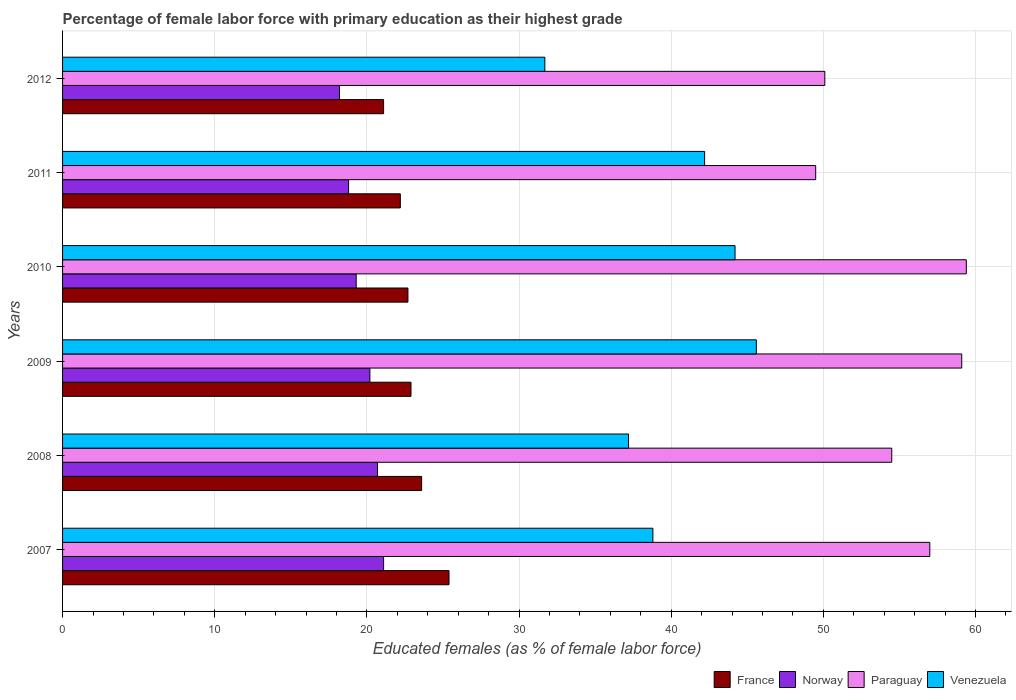How many bars are there on the 4th tick from the top?
Offer a very short reply. 4. How many bars are there on the 2nd tick from the bottom?
Your response must be concise. 4. What is the label of the 5th group of bars from the top?
Your response must be concise. 2008. What is the percentage of female labor force with primary education in Norway in 2012?
Make the answer very short. 18.2. Across all years, what is the maximum percentage of female labor force with primary education in Norway?
Your response must be concise. 21.1. Across all years, what is the minimum percentage of female labor force with primary education in Venezuela?
Give a very brief answer. 31.7. What is the total percentage of female labor force with primary education in Paraguay in the graph?
Offer a very short reply. 329.6. What is the difference between the percentage of female labor force with primary education in Venezuela in 2011 and that in 2012?
Ensure brevity in your answer.  10.5. What is the difference between the percentage of female labor force with primary education in Norway in 2008 and the percentage of female labor force with primary education in France in 2012?
Give a very brief answer. -0.4. What is the average percentage of female labor force with primary education in Venezuela per year?
Your response must be concise. 39.95. In the year 2011, what is the difference between the percentage of female labor force with primary education in Norway and percentage of female labor force with primary education in Paraguay?
Your response must be concise. -30.7. What is the ratio of the percentage of female labor force with primary education in France in 2009 to that in 2010?
Offer a very short reply. 1.01. What is the difference between the highest and the second highest percentage of female labor force with primary education in France?
Give a very brief answer. 1.8. What is the difference between the highest and the lowest percentage of female labor force with primary education in Venezuela?
Your answer should be compact. 13.9. Is the sum of the percentage of female labor force with primary education in France in 2009 and 2010 greater than the maximum percentage of female labor force with primary education in Venezuela across all years?
Keep it short and to the point. Yes. Is it the case that in every year, the sum of the percentage of female labor force with primary education in Paraguay and percentage of female labor force with primary education in France is greater than the sum of percentage of female labor force with primary education in Venezuela and percentage of female labor force with primary education in Norway?
Provide a succinct answer. No. What does the 2nd bar from the top in 2009 represents?
Offer a very short reply. Paraguay. Is it the case that in every year, the sum of the percentage of female labor force with primary education in Norway and percentage of female labor force with primary education in France is greater than the percentage of female labor force with primary education in Paraguay?
Make the answer very short. No. How many bars are there?
Provide a succinct answer. 24. What is the difference between two consecutive major ticks on the X-axis?
Offer a very short reply. 10. Does the graph contain any zero values?
Provide a succinct answer. No. Does the graph contain grids?
Provide a succinct answer. Yes. Where does the legend appear in the graph?
Your answer should be compact. Bottom right. How are the legend labels stacked?
Offer a very short reply. Horizontal. What is the title of the graph?
Offer a very short reply. Percentage of female labor force with primary education as their highest grade. Does "Jordan" appear as one of the legend labels in the graph?
Your response must be concise. No. What is the label or title of the X-axis?
Give a very brief answer. Educated females (as % of female labor force). What is the Educated females (as % of female labor force) in France in 2007?
Give a very brief answer. 25.4. What is the Educated females (as % of female labor force) in Norway in 2007?
Ensure brevity in your answer.  21.1. What is the Educated females (as % of female labor force) of Paraguay in 2007?
Your response must be concise. 57. What is the Educated females (as % of female labor force) in Venezuela in 2007?
Your answer should be very brief. 38.8. What is the Educated females (as % of female labor force) in France in 2008?
Offer a very short reply. 23.6. What is the Educated females (as % of female labor force) of Norway in 2008?
Ensure brevity in your answer.  20.7. What is the Educated females (as % of female labor force) of Paraguay in 2008?
Provide a succinct answer. 54.5. What is the Educated females (as % of female labor force) in Venezuela in 2008?
Provide a succinct answer. 37.2. What is the Educated females (as % of female labor force) of France in 2009?
Provide a succinct answer. 22.9. What is the Educated females (as % of female labor force) of Norway in 2009?
Offer a very short reply. 20.2. What is the Educated females (as % of female labor force) in Paraguay in 2009?
Your answer should be very brief. 59.1. What is the Educated females (as % of female labor force) in Venezuela in 2009?
Your response must be concise. 45.6. What is the Educated females (as % of female labor force) of France in 2010?
Ensure brevity in your answer.  22.7. What is the Educated females (as % of female labor force) of Norway in 2010?
Offer a very short reply. 19.3. What is the Educated females (as % of female labor force) in Paraguay in 2010?
Give a very brief answer. 59.4. What is the Educated females (as % of female labor force) of Venezuela in 2010?
Your answer should be very brief. 44.2. What is the Educated females (as % of female labor force) in France in 2011?
Provide a short and direct response. 22.2. What is the Educated females (as % of female labor force) in Norway in 2011?
Give a very brief answer. 18.8. What is the Educated females (as % of female labor force) in Paraguay in 2011?
Provide a short and direct response. 49.5. What is the Educated females (as % of female labor force) in Venezuela in 2011?
Ensure brevity in your answer.  42.2. What is the Educated females (as % of female labor force) in France in 2012?
Keep it short and to the point. 21.1. What is the Educated females (as % of female labor force) in Norway in 2012?
Make the answer very short. 18.2. What is the Educated females (as % of female labor force) of Paraguay in 2012?
Offer a very short reply. 50.1. What is the Educated females (as % of female labor force) in Venezuela in 2012?
Your answer should be compact. 31.7. Across all years, what is the maximum Educated females (as % of female labor force) in France?
Offer a very short reply. 25.4. Across all years, what is the maximum Educated females (as % of female labor force) of Norway?
Offer a terse response. 21.1. Across all years, what is the maximum Educated females (as % of female labor force) in Paraguay?
Offer a very short reply. 59.4. Across all years, what is the maximum Educated females (as % of female labor force) in Venezuela?
Make the answer very short. 45.6. Across all years, what is the minimum Educated females (as % of female labor force) of France?
Your answer should be very brief. 21.1. Across all years, what is the minimum Educated females (as % of female labor force) in Norway?
Ensure brevity in your answer.  18.2. Across all years, what is the minimum Educated females (as % of female labor force) of Paraguay?
Offer a terse response. 49.5. Across all years, what is the minimum Educated females (as % of female labor force) of Venezuela?
Give a very brief answer. 31.7. What is the total Educated females (as % of female labor force) in France in the graph?
Provide a short and direct response. 137.9. What is the total Educated females (as % of female labor force) of Norway in the graph?
Ensure brevity in your answer.  118.3. What is the total Educated females (as % of female labor force) of Paraguay in the graph?
Make the answer very short. 329.6. What is the total Educated females (as % of female labor force) in Venezuela in the graph?
Offer a very short reply. 239.7. What is the difference between the Educated females (as % of female labor force) in France in 2007 and that in 2008?
Make the answer very short. 1.8. What is the difference between the Educated females (as % of female labor force) in Paraguay in 2007 and that in 2008?
Provide a short and direct response. 2.5. What is the difference between the Educated females (as % of female labor force) in Venezuela in 2007 and that in 2008?
Provide a succinct answer. 1.6. What is the difference between the Educated females (as % of female labor force) in Norway in 2007 and that in 2009?
Give a very brief answer. 0.9. What is the difference between the Educated females (as % of female labor force) in Venezuela in 2007 and that in 2009?
Your answer should be very brief. -6.8. What is the difference between the Educated females (as % of female labor force) in France in 2007 and that in 2010?
Give a very brief answer. 2.7. What is the difference between the Educated females (as % of female labor force) of France in 2007 and that in 2011?
Offer a terse response. 3.2. What is the difference between the Educated females (as % of female labor force) in Norway in 2007 and that in 2011?
Your answer should be compact. 2.3. What is the difference between the Educated females (as % of female labor force) of Paraguay in 2007 and that in 2011?
Provide a short and direct response. 7.5. What is the difference between the Educated females (as % of female labor force) in Norway in 2007 and that in 2012?
Give a very brief answer. 2.9. What is the difference between the Educated females (as % of female labor force) of Paraguay in 2007 and that in 2012?
Provide a short and direct response. 6.9. What is the difference between the Educated females (as % of female labor force) of Norway in 2008 and that in 2009?
Your answer should be compact. 0.5. What is the difference between the Educated females (as % of female labor force) of Venezuela in 2008 and that in 2009?
Your response must be concise. -8.4. What is the difference between the Educated females (as % of female labor force) of France in 2008 and that in 2010?
Your answer should be very brief. 0.9. What is the difference between the Educated females (as % of female labor force) in Paraguay in 2008 and that in 2010?
Keep it short and to the point. -4.9. What is the difference between the Educated females (as % of female labor force) of Norway in 2008 and that in 2011?
Ensure brevity in your answer.  1.9. What is the difference between the Educated females (as % of female labor force) in Paraguay in 2008 and that in 2011?
Offer a terse response. 5. What is the difference between the Educated females (as % of female labor force) in Venezuela in 2008 and that in 2011?
Your answer should be very brief. -5. What is the difference between the Educated females (as % of female labor force) of Paraguay in 2008 and that in 2012?
Your response must be concise. 4.4. What is the difference between the Educated females (as % of female labor force) in Venezuela in 2008 and that in 2012?
Your answer should be very brief. 5.5. What is the difference between the Educated females (as % of female labor force) of France in 2009 and that in 2010?
Keep it short and to the point. 0.2. What is the difference between the Educated females (as % of female labor force) of Norway in 2009 and that in 2010?
Your answer should be very brief. 0.9. What is the difference between the Educated females (as % of female labor force) in Norway in 2009 and that in 2011?
Your answer should be very brief. 1.4. What is the difference between the Educated females (as % of female labor force) in Paraguay in 2009 and that in 2011?
Your answer should be very brief. 9.6. What is the difference between the Educated females (as % of female labor force) of Venezuela in 2009 and that in 2011?
Your response must be concise. 3.4. What is the difference between the Educated females (as % of female labor force) of France in 2010 and that in 2011?
Offer a very short reply. 0.5. What is the difference between the Educated females (as % of female labor force) in Paraguay in 2010 and that in 2011?
Provide a succinct answer. 9.9. What is the difference between the Educated females (as % of female labor force) in France in 2010 and that in 2012?
Give a very brief answer. 1.6. What is the difference between the Educated females (as % of female labor force) of Paraguay in 2010 and that in 2012?
Keep it short and to the point. 9.3. What is the difference between the Educated females (as % of female labor force) in Venezuela in 2010 and that in 2012?
Your answer should be compact. 12.5. What is the difference between the Educated females (as % of female labor force) of Paraguay in 2011 and that in 2012?
Your answer should be compact. -0.6. What is the difference between the Educated females (as % of female labor force) of France in 2007 and the Educated females (as % of female labor force) of Norway in 2008?
Your answer should be very brief. 4.7. What is the difference between the Educated females (as % of female labor force) of France in 2007 and the Educated females (as % of female labor force) of Paraguay in 2008?
Give a very brief answer. -29.1. What is the difference between the Educated females (as % of female labor force) of Norway in 2007 and the Educated females (as % of female labor force) of Paraguay in 2008?
Your answer should be compact. -33.4. What is the difference between the Educated females (as % of female labor force) of Norway in 2007 and the Educated females (as % of female labor force) of Venezuela in 2008?
Give a very brief answer. -16.1. What is the difference between the Educated females (as % of female labor force) in Paraguay in 2007 and the Educated females (as % of female labor force) in Venezuela in 2008?
Your answer should be compact. 19.8. What is the difference between the Educated females (as % of female labor force) in France in 2007 and the Educated females (as % of female labor force) in Norway in 2009?
Your answer should be compact. 5.2. What is the difference between the Educated females (as % of female labor force) in France in 2007 and the Educated females (as % of female labor force) in Paraguay in 2009?
Your answer should be compact. -33.7. What is the difference between the Educated females (as % of female labor force) of France in 2007 and the Educated females (as % of female labor force) of Venezuela in 2009?
Offer a very short reply. -20.2. What is the difference between the Educated females (as % of female labor force) in Norway in 2007 and the Educated females (as % of female labor force) in Paraguay in 2009?
Make the answer very short. -38. What is the difference between the Educated females (as % of female labor force) in Norway in 2007 and the Educated females (as % of female labor force) in Venezuela in 2009?
Your response must be concise. -24.5. What is the difference between the Educated females (as % of female labor force) in France in 2007 and the Educated females (as % of female labor force) in Paraguay in 2010?
Offer a terse response. -34. What is the difference between the Educated females (as % of female labor force) in France in 2007 and the Educated females (as % of female labor force) in Venezuela in 2010?
Your answer should be very brief. -18.8. What is the difference between the Educated females (as % of female labor force) of Norway in 2007 and the Educated females (as % of female labor force) of Paraguay in 2010?
Offer a terse response. -38.3. What is the difference between the Educated females (as % of female labor force) in Norway in 2007 and the Educated females (as % of female labor force) in Venezuela in 2010?
Provide a succinct answer. -23.1. What is the difference between the Educated females (as % of female labor force) of France in 2007 and the Educated females (as % of female labor force) of Paraguay in 2011?
Keep it short and to the point. -24.1. What is the difference between the Educated females (as % of female labor force) of France in 2007 and the Educated females (as % of female labor force) of Venezuela in 2011?
Your answer should be very brief. -16.8. What is the difference between the Educated females (as % of female labor force) in Norway in 2007 and the Educated females (as % of female labor force) in Paraguay in 2011?
Ensure brevity in your answer.  -28.4. What is the difference between the Educated females (as % of female labor force) in Norway in 2007 and the Educated females (as % of female labor force) in Venezuela in 2011?
Ensure brevity in your answer.  -21.1. What is the difference between the Educated females (as % of female labor force) of Paraguay in 2007 and the Educated females (as % of female labor force) of Venezuela in 2011?
Give a very brief answer. 14.8. What is the difference between the Educated females (as % of female labor force) in France in 2007 and the Educated females (as % of female labor force) in Norway in 2012?
Your answer should be very brief. 7.2. What is the difference between the Educated females (as % of female labor force) of France in 2007 and the Educated females (as % of female labor force) of Paraguay in 2012?
Provide a succinct answer. -24.7. What is the difference between the Educated females (as % of female labor force) in France in 2007 and the Educated females (as % of female labor force) in Venezuela in 2012?
Make the answer very short. -6.3. What is the difference between the Educated females (as % of female labor force) of Norway in 2007 and the Educated females (as % of female labor force) of Paraguay in 2012?
Provide a short and direct response. -29. What is the difference between the Educated females (as % of female labor force) in Norway in 2007 and the Educated females (as % of female labor force) in Venezuela in 2012?
Offer a terse response. -10.6. What is the difference between the Educated females (as % of female labor force) in Paraguay in 2007 and the Educated females (as % of female labor force) in Venezuela in 2012?
Give a very brief answer. 25.3. What is the difference between the Educated females (as % of female labor force) in France in 2008 and the Educated females (as % of female labor force) in Norway in 2009?
Your answer should be compact. 3.4. What is the difference between the Educated females (as % of female labor force) in France in 2008 and the Educated females (as % of female labor force) in Paraguay in 2009?
Your answer should be compact. -35.5. What is the difference between the Educated females (as % of female labor force) of France in 2008 and the Educated females (as % of female labor force) of Venezuela in 2009?
Keep it short and to the point. -22. What is the difference between the Educated females (as % of female labor force) of Norway in 2008 and the Educated females (as % of female labor force) of Paraguay in 2009?
Make the answer very short. -38.4. What is the difference between the Educated females (as % of female labor force) in Norway in 2008 and the Educated females (as % of female labor force) in Venezuela in 2009?
Your answer should be compact. -24.9. What is the difference between the Educated females (as % of female labor force) of France in 2008 and the Educated females (as % of female labor force) of Paraguay in 2010?
Give a very brief answer. -35.8. What is the difference between the Educated females (as % of female labor force) in France in 2008 and the Educated females (as % of female labor force) in Venezuela in 2010?
Give a very brief answer. -20.6. What is the difference between the Educated females (as % of female labor force) in Norway in 2008 and the Educated females (as % of female labor force) in Paraguay in 2010?
Make the answer very short. -38.7. What is the difference between the Educated females (as % of female labor force) of Norway in 2008 and the Educated females (as % of female labor force) of Venezuela in 2010?
Give a very brief answer. -23.5. What is the difference between the Educated females (as % of female labor force) of France in 2008 and the Educated females (as % of female labor force) of Norway in 2011?
Offer a terse response. 4.8. What is the difference between the Educated females (as % of female labor force) in France in 2008 and the Educated females (as % of female labor force) in Paraguay in 2011?
Ensure brevity in your answer.  -25.9. What is the difference between the Educated females (as % of female labor force) in France in 2008 and the Educated females (as % of female labor force) in Venezuela in 2011?
Keep it short and to the point. -18.6. What is the difference between the Educated females (as % of female labor force) of Norway in 2008 and the Educated females (as % of female labor force) of Paraguay in 2011?
Make the answer very short. -28.8. What is the difference between the Educated females (as % of female labor force) of Norway in 2008 and the Educated females (as % of female labor force) of Venezuela in 2011?
Make the answer very short. -21.5. What is the difference between the Educated females (as % of female labor force) in France in 2008 and the Educated females (as % of female labor force) in Norway in 2012?
Your answer should be very brief. 5.4. What is the difference between the Educated females (as % of female labor force) in France in 2008 and the Educated females (as % of female labor force) in Paraguay in 2012?
Make the answer very short. -26.5. What is the difference between the Educated females (as % of female labor force) of Norway in 2008 and the Educated females (as % of female labor force) of Paraguay in 2012?
Provide a short and direct response. -29.4. What is the difference between the Educated females (as % of female labor force) of Paraguay in 2008 and the Educated females (as % of female labor force) of Venezuela in 2012?
Give a very brief answer. 22.8. What is the difference between the Educated females (as % of female labor force) of France in 2009 and the Educated females (as % of female labor force) of Norway in 2010?
Your response must be concise. 3.6. What is the difference between the Educated females (as % of female labor force) in France in 2009 and the Educated females (as % of female labor force) in Paraguay in 2010?
Your response must be concise. -36.5. What is the difference between the Educated females (as % of female labor force) in France in 2009 and the Educated females (as % of female labor force) in Venezuela in 2010?
Provide a short and direct response. -21.3. What is the difference between the Educated females (as % of female labor force) in Norway in 2009 and the Educated females (as % of female labor force) in Paraguay in 2010?
Provide a succinct answer. -39.2. What is the difference between the Educated females (as % of female labor force) in Norway in 2009 and the Educated females (as % of female labor force) in Venezuela in 2010?
Provide a short and direct response. -24. What is the difference between the Educated females (as % of female labor force) of Paraguay in 2009 and the Educated females (as % of female labor force) of Venezuela in 2010?
Your response must be concise. 14.9. What is the difference between the Educated females (as % of female labor force) in France in 2009 and the Educated females (as % of female labor force) in Norway in 2011?
Keep it short and to the point. 4.1. What is the difference between the Educated females (as % of female labor force) in France in 2009 and the Educated females (as % of female labor force) in Paraguay in 2011?
Offer a very short reply. -26.6. What is the difference between the Educated females (as % of female labor force) in France in 2009 and the Educated females (as % of female labor force) in Venezuela in 2011?
Your answer should be very brief. -19.3. What is the difference between the Educated females (as % of female labor force) in Norway in 2009 and the Educated females (as % of female labor force) in Paraguay in 2011?
Give a very brief answer. -29.3. What is the difference between the Educated females (as % of female labor force) in Norway in 2009 and the Educated females (as % of female labor force) in Venezuela in 2011?
Keep it short and to the point. -22. What is the difference between the Educated females (as % of female labor force) of France in 2009 and the Educated females (as % of female labor force) of Paraguay in 2012?
Offer a terse response. -27.2. What is the difference between the Educated females (as % of female labor force) in France in 2009 and the Educated females (as % of female labor force) in Venezuela in 2012?
Offer a terse response. -8.8. What is the difference between the Educated females (as % of female labor force) of Norway in 2009 and the Educated females (as % of female labor force) of Paraguay in 2012?
Offer a very short reply. -29.9. What is the difference between the Educated females (as % of female labor force) of Paraguay in 2009 and the Educated females (as % of female labor force) of Venezuela in 2012?
Offer a terse response. 27.4. What is the difference between the Educated females (as % of female labor force) of France in 2010 and the Educated females (as % of female labor force) of Paraguay in 2011?
Give a very brief answer. -26.8. What is the difference between the Educated females (as % of female labor force) in France in 2010 and the Educated females (as % of female labor force) in Venezuela in 2011?
Offer a terse response. -19.5. What is the difference between the Educated females (as % of female labor force) in Norway in 2010 and the Educated females (as % of female labor force) in Paraguay in 2011?
Your answer should be compact. -30.2. What is the difference between the Educated females (as % of female labor force) of Norway in 2010 and the Educated females (as % of female labor force) of Venezuela in 2011?
Make the answer very short. -22.9. What is the difference between the Educated females (as % of female labor force) of France in 2010 and the Educated females (as % of female labor force) of Paraguay in 2012?
Keep it short and to the point. -27.4. What is the difference between the Educated females (as % of female labor force) in Norway in 2010 and the Educated females (as % of female labor force) in Paraguay in 2012?
Your response must be concise. -30.8. What is the difference between the Educated females (as % of female labor force) of Norway in 2010 and the Educated females (as % of female labor force) of Venezuela in 2012?
Your answer should be very brief. -12.4. What is the difference between the Educated females (as % of female labor force) in Paraguay in 2010 and the Educated females (as % of female labor force) in Venezuela in 2012?
Your response must be concise. 27.7. What is the difference between the Educated females (as % of female labor force) of France in 2011 and the Educated females (as % of female labor force) of Norway in 2012?
Offer a terse response. 4. What is the difference between the Educated females (as % of female labor force) in France in 2011 and the Educated females (as % of female labor force) in Paraguay in 2012?
Your answer should be compact. -27.9. What is the difference between the Educated females (as % of female labor force) of Norway in 2011 and the Educated females (as % of female labor force) of Paraguay in 2012?
Keep it short and to the point. -31.3. What is the average Educated females (as % of female labor force) of France per year?
Provide a short and direct response. 22.98. What is the average Educated females (as % of female labor force) in Norway per year?
Keep it short and to the point. 19.72. What is the average Educated females (as % of female labor force) in Paraguay per year?
Provide a short and direct response. 54.93. What is the average Educated females (as % of female labor force) of Venezuela per year?
Provide a short and direct response. 39.95. In the year 2007, what is the difference between the Educated females (as % of female labor force) of France and Educated females (as % of female labor force) of Norway?
Make the answer very short. 4.3. In the year 2007, what is the difference between the Educated females (as % of female labor force) in France and Educated females (as % of female labor force) in Paraguay?
Your response must be concise. -31.6. In the year 2007, what is the difference between the Educated females (as % of female labor force) of Norway and Educated females (as % of female labor force) of Paraguay?
Give a very brief answer. -35.9. In the year 2007, what is the difference between the Educated females (as % of female labor force) in Norway and Educated females (as % of female labor force) in Venezuela?
Offer a very short reply. -17.7. In the year 2007, what is the difference between the Educated females (as % of female labor force) of Paraguay and Educated females (as % of female labor force) of Venezuela?
Offer a very short reply. 18.2. In the year 2008, what is the difference between the Educated females (as % of female labor force) in France and Educated females (as % of female labor force) in Norway?
Provide a short and direct response. 2.9. In the year 2008, what is the difference between the Educated females (as % of female labor force) in France and Educated females (as % of female labor force) in Paraguay?
Your answer should be very brief. -30.9. In the year 2008, what is the difference between the Educated females (as % of female labor force) of Norway and Educated females (as % of female labor force) of Paraguay?
Provide a short and direct response. -33.8. In the year 2008, what is the difference between the Educated females (as % of female labor force) of Norway and Educated females (as % of female labor force) of Venezuela?
Provide a short and direct response. -16.5. In the year 2009, what is the difference between the Educated females (as % of female labor force) of France and Educated females (as % of female labor force) of Paraguay?
Ensure brevity in your answer.  -36.2. In the year 2009, what is the difference between the Educated females (as % of female labor force) in France and Educated females (as % of female labor force) in Venezuela?
Your response must be concise. -22.7. In the year 2009, what is the difference between the Educated females (as % of female labor force) of Norway and Educated females (as % of female labor force) of Paraguay?
Provide a short and direct response. -38.9. In the year 2009, what is the difference between the Educated females (as % of female labor force) in Norway and Educated females (as % of female labor force) in Venezuela?
Make the answer very short. -25.4. In the year 2009, what is the difference between the Educated females (as % of female labor force) of Paraguay and Educated females (as % of female labor force) of Venezuela?
Provide a succinct answer. 13.5. In the year 2010, what is the difference between the Educated females (as % of female labor force) of France and Educated females (as % of female labor force) of Norway?
Make the answer very short. 3.4. In the year 2010, what is the difference between the Educated females (as % of female labor force) of France and Educated females (as % of female labor force) of Paraguay?
Offer a terse response. -36.7. In the year 2010, what is the difference between the Educated females (as % of female labor force) in France and Educated females (as % of female labor force) in Venezuela?
Your answer should be compact. -21.5. In the year 2010, what is the difference between the Educated females (as % of female labor force) in Norway and Educated females (as % of female labor force) in Paraguay?
Ensure brevity in your answer.  -40.1. In the year 2010, what is the difference between the Educated females (as % of female labor force) of Norway and Educated females (as % of female labor force) of Venezuela?
Offer a very short reply. -24.9. In the year 2011, what is the difference between the Educated females (as % of female labor force) of France and Educated females (as % of female labor force) of Paraguay?
Make the answer very short. -27.3. In the year 2011, what is the difference between the Educated females (as % of female labor force) in France and Educated females (as % of female labor force) in Venezuela?
Your answer should be compact. -20. In the year 2011, what is the difference between the Educated females (as % of female labor force) of Norway and Educated females (as % of female labor force) of Paraguay?
Give a very brief answer. -30.7. In the year 2011, what is the difference between the Educated females (as % of female labor force) in Norway and Educated females (as % of female labor force) in Venezuela?
Keep it short and to the point. -23.4. In the year 2012, what is the difference between the Educated females (as % of female labor force) in France and Educated females (as % of female labor force) in Norway?
Make the answer very short. 2.9. In the year 2012, what is the difference between the Educated females (as % of female labor force) in Norway and Educated females (as % of female labor force) in Paraguay?
Your response must be concise. -31.9. In the year 2012, what is the difference between the Educated females (as % of female labor force) in Norway and Educated females (as % of female labor force) in Venezuela?
Ensure brevity in your answer.  -13.5. In the year 2012, what is the difference between the Educated females (as % of female labor force) in Paraguay and Educated females (as % of female labor force) in Venezuela?
Your response must be concise. 18.4. What is the ratio of the Educated females (as % of female labor force) of France in 2007 to that in 2008?
Your answer should be very brief. 1.08. What is the ratio of the Educated females (as % of female labor force) in Norway in 2007 to that in 2008?
Offer a very short reply. 1.02. What is the ratio of the Educated females (as % of female labor force) of Paraguay in 2007 to that in 2008?
Provide a succinct answer. 1.05. What is the ratio of the Educated females (as % of female labor force) in Venezuela in 2007 to that in 2008?
Your answer should be very brief. 1.04. What is the ratio of the Educated females (as % of female labor force) in France in 2007 to that in 2009?
Your answer should be very brief. 1.11. What is the ratio of the Educated females (as % of female labor force) of Norway in 2007 to that in 2009?
Keep it short and to the point. 1.04. What is the ratio of the Educated females (as % of female labor force) of Paraguay in 2007 to that in 2009?
Your answer should be compact. 0.96. What is the ratio of the Educated females (as % of female labor force) of Venezuela in 2007 to that in 2009?
Your answer should be compact. 0.85. What is the ratio of the Educated females (as % of female labor force) of France in 2007 to that in 2010?
Your answer should be very brief. 1.12. What is the ratio of the Educated females (as % of female labor force) of Norway in 2007 to that in 2010?
Offer a very short reply. 1.09. What is the ratio of the Educated females (as % of female labor force) of Paraguay in 2007 to that in 2010?
Provide a short and direct response. 0.96. What is the ratio of the Educated females (as % of female labor force) in Venezuela in 2007 to that in 2010?
Your response must be concise. 0.88. What is the ratio of the Educated females (as % of female labor force) of France in 2007 to that in 2011?
Give a very brief answer. 1.14. What is the ratio of the Educated females (as % of female labor force) in Norway in 2007 to that in 2011?
Provide a succinct answer. 1.12. What is the ratio of the Educated females (as % of female labor force) of Paraguay in 2007 to that in 2011?
Offer a terse response. 1.15. What is the ratio of the Educated females (as % of female labor force) in Venezuela in 2007 to that in 2011?
Your response must be concise. 0.92. What is the ratio of the Educated females (as % of female labor force) in France in 2007 to that in 2012?
Give a very brief answer. 1.2. What is the ratio of the Educated females (as % of female labor force) of Norway in 2007 to that in 2012?
Offer a terse response. 1.16. What is the ratio of the Educated females (as % of female labor force) in Paraguay in 2007 to that in 2012?
Offer a terse response. 1.14. What is the ratio of the Educated females (as % of female labor force) of Venezuela in 2007 to that in 2012?
Your answer should be compact. 1.22. What is the ratio of the Educated females (as % of female labor force) in France in 2008 to that in 2009?
Offer a very short reply. 1.03. What is the ratio of the Educated females (as % of female labor force) in Norway in 2008 to that in 2009?
Ensure brevity in your answer.  1.02. What is the ratio of the Educated females (as % of female labor force) in Paraguay in 2008 to that in 2009?
Provide a succinct answer. 0.92. What is the ratio of the Educated females (as % of female labor force) in Venezuela in 2008 to that in 2009?
Provide a short and direct response. 0.82. What is the ratio of the Educated females (as % of female labor force) in France in 2008 to that in 2010?
Make the answer very short. 1.04. What is the ratio of the Educated females (as % of female labor force) of Norway in 2008 to that in 2010?
Your answer should be compact. 1.07. What is the ratio of the Educated females (as % of female labor force) in Paraguay in 2008 to that in 2010?
Offer a terse response. 0.92. What is the ratio of the Educated females (as % of female labor force) in Venezuela in 2008 to that in 2010?
Offer a very short reply. 0.84. What is the ratio of the Educated females (as % of female labor force) of France in 2008 to that in 2011?
Provide a succinct answer. 1.06. What is the ratio of the Educated females (as % of female labor force) in Norway in 2008 to that in 2011?
Make the answer very short. 1.1. What is the ratio of the Educated females (as % of female labor force) of Paraguay in 2008 to that in 2011?
Provide a succinct answer. 1.1. What is the ratio of the Educated females (as % of female labor force) of Venezuela in 2008 to that in 2011?
Give a very brief answer. 0.88. What is the ratio of the Educated females (as % of female labor force) in France in 2008 to that in 2012?
Your response must be concise. 1.12. What is the ratio of the Educated females (as % of female labor force) of Norway in 2008 to that in 2012?
Make the answer very short. 1.14. What is the ratio of the Educated females (as % of female labor force) of Paraguay in 2008 to that in 2012?
Offer a very short reply. 1.09. What is the ratio of the Educated females (as % of female labor force) of Venezuela in 2008 to that in 2012?
Your response must be concise. 1.17. What is the ratio of the Educated females (as % of female labor force) of France in 2009 to that in 2010?
Ensure brevity in your answer.  1.01. What is the ratio of the Educated females (as % of female labor force) of Norway in 2009 to that in 2010?
Ensure brevity in your answer.  1.05. What is the ratio of the Educated females (as % of female labor force) of Paraguay in 2009 to that in 2010?
Give a very brief answer. 0.99. What is the ratio of the Educated females (as % of female labor force) in Venezuela in 2009 to that in 2010?
Keep it short and to the point. 1.03. What is the ratio of the Educated females (as % of female labor force) of France in 2009 to that in 2011?
Give a very brief answer. 1.03. What is the ratio of the Educated females (as % of female labor force) of Norway in 2009 to that in 2011?
Provide a short and direct response. 1.07. What is the ratio of the Educated females (as % of female labor force) in Paraguay in 2009 to that in 2011?
Ensure brevity in your answer.  1.19. What is the ratio of the Educated females (as % of female labor force) in Venezuela in 2009 to that in 2011?
Keep it short and to the point. 1.08. What is the ratio of the Educated females (as % of female labor force) of France in 2009 to that in 2012?
Make the answer very short. 1.09. What is the ratio of the Educated females (as % of female labor force) of Norway in 2009 to that in 2012?
Ensure brevity in your answer.  1.11. What is the ratio of the Educated females (as % of female labor force) in Paraguay in 2009 to that in 2012?
Make the answer very short. 1.18. What is the ratio of the Educated females (as % of female labor force) of Venezuela in 2009 to that in 2012?
Keep it short and to the point. 1.44. What is the ratio of the Educated females (as % of female labor force) of France in 2010 to that in 2011?
Provide a succinct answer. 1.02. What is the ratio of the Educated females (as % of female labor force) of Norway in 2010 to that in 2011?
Give a very brief answer. 1.03. What is the ratio of the Educated females (as % of female labor force) of Venezuela in 2010 to that in 2011?
Offer a very short reply. 1.05. What is the ratio of the Educated females (as % of female labor force) of France in 2010 to that in 2012?
Offer a terse response. 1.08. What is the ratio of the Educated females (as % of female labor force) of Norway in 2010 to that in 2012?
Your answer should be compact. 1.06. What is the ratio of the Educated females (as % of female labor force) of Paraguay in 2010 to that in 2012?
Ensure brevity in your answer.  1.19. What is the ratio of the Educated females (as % of female labor force) of Venezuela in 2010 to that in 2012?
Offer a terse response. 1.39. What is the ratio of the Educated females (as % of female labor force) of France in 2011 to that in 2012?
Offer a terse response. 1.05. What is the ratio of the Educated females (as % of female labor force) in Norway in 2011 to that in 2012?
Your response must be concise. 1.03. What is the ratio of the Educated females (as % of female labor force) in Venezuela in 2011 to that in 2012?
Your answer should be very brief. 1.33. What is the difference between the highest and the second highest Educated females (as % of female labor force) of France?
Offer a terse response. 1.8. What is the difference between the highest and the second highest Educated females (as % of female labor force) of Paraguay?
Make the answer very short. 0.3. 